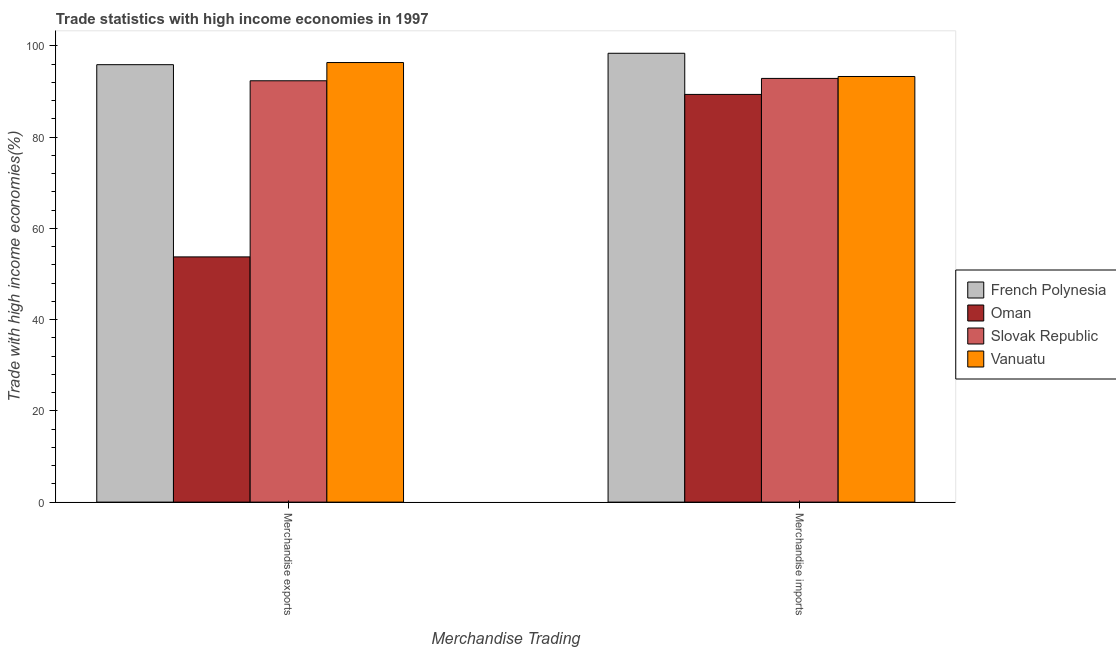How many different coloured bars are there?
Offer a very short reply. 4. Are the number of bars per tick equal to the number of legend labels?
Make the answer very short. Yes. Are the number of bars on each tick of the X-axis equal?
Offer a terse response. Yes. How many bars are there on the 1st tick from the right?
Give a very brief answer. 4. What is the merchandise exports in Oman?
Your answer should be compact. 53.76. Across all countries, what is the maximum merchandise imports?
Offer a terse response. 98.4. Across all countries, what is the minimum merchandise exports?
Provide a short and direct response. 53.76. In which country was the merchandise imports maximum?
Keep it short and to the point. French Polynesia. In which country was the merchandise exports minimum?
Offer a very short reply. Oman. What is the total merchandise imports in the graph?
Make the answer very short. 373.96. What is the difference between the merchandise imports in Slovak Republic and that in Vanuatu?
Keep it short and to the point. -0.42. What is the difference between the merchandise imports in French Polynesia and the merchandise exports in Slovak Republic?
Offer a terse response. 6.03. What is the average merchandise imports per country?
Your answer should be compact. 93.49. What is the difference between the merchandise imports and merchandise exports in French Polynesia?
Give a very brief answer. 2.5. In how many countries, is the merchandise imports greater than 56 %?
Offer a terse response. 4. What is the ratio of the merchandise exports in Slovak Republic to that in Vanuatu?
Provide a short and direct response. 0.96. What does the 4th bar from the left in Merchandise exports represents?
Give a very brief answer. Vanuatu. What does the 3rd bar from the right in Merchandise imports represents?
Make the answer very short. Oman. What is the difference between two consecutive major ticks on the Y-axis?
Your response must be concise. 20. Where does the legend appear in the graph?
Ensure brevity in your answer.  Center right. How are the legend labels stacked?
Provide a succinct answer. Vertical. What is the title of the graph?
Provide a succinct answer. Trade statistics with high income economies in 1997. Does "South Africa" appear as one of the legend labels in the graph?
Provide a short and direct response. No. What is the label or title of the X-axis?
Provide a short and direct response. Merchandise Trading. What is the label or title of the Y-axis?
Provide a succinct answer. Trade with high income economies(%). What is the Trade with high income economies(%) in French Polynesia in Merchandise exports?
Ensure brevity in your answer.  95.9. What is the Trade with high income economies(%) of Oman in Merchandise exports?
Ensure brevity in your answer.  53.76. What is the Trade with high income economies(%) of Slovak Republic in Merchandise exports?
Your answer should be compact. 92.37. What is the Trade with high income economies(%) in Vanuatu in Merchandise exports?
Your answer should be compact. 96.36. What is the Trade with high income economies(%) in French Polynesia in Merchandise imports?
Your response must be concise. 98.4. What is the Trade with high income economies(%) of Oman in Merchandise imports?
Your response must be concise. 89.38. What is the Trade with high income economies(%) in Slovak Republic in Merchandise imports?
Make the answer very short. 92.88. What is the Trade with high income economies(%) in Vanuatu in Merchandise imports?
Provide a succinct answer. 93.3. Across all Merchandise Trading, what is the maximum Trade with high income economies(%) in French Polynesia?
Offer a terse response. 98.4. Across all Merchandise Trading, what is the maximum Trade with high income economies(%) in Oman?
Give a very brief answer. 89.38. Across all Merchandise Trading, what is the maximum Trade with high income economies(%) in Slovak Republic?
Provide a succinct answer. 92.88. Across all Merchandise Trading, what is the maximum Trade with high income economies(%) in Vanuatu?
Make the answer very short. 96.36. Across all Merchandise Trading, what is the minimum Trade with high income economies(%) in French Polynesia?
Give a very brief answer. 95.9. Across all Merchandise Trading, what is the minimum Trade with high income economies(%) in Oman?
Your answer should be compact. 53.76. Across all Merchandise Trading, what is the minimum Trade with high income economies(%) of Slovak Republic?
Your response must be concise. 92.37. Across all Merchandise Trading, what is the minimum Trade with high income economies(%) of Vanuatu?
Your response must be concise. 93.3. What is the total Trade with high income economies(%) in French Polynesia in the graph?
Offer a very short reply. 194.29. What is the total Trade with high income economies(%) of Oman in the graph?
Your response must be concise. 143.14. What is the total Trade with high income economies(%) in Slovak Republic in the graph?
Provide a succinct answer. 185.25. What is the total Trade with high income economies(%) of Vanuatu in the graph?
Ensure brevity in your answer.  189.67. What is the difference between the Trade with high income economies(%) of French Polynesia in Merchandise exports and that in Merchandise imports?
Offer a terse response. -2.5. What is the difference between the Trade with high income economies(%) in Oman in Merchandise exports and that in Merchandise imports?
Provide a succinct answer. -35.62. What is the difference between the Trade with high income economies(%) of Slovak Republic in Merchandise exports and that in Merchandise imports?
Offer a very short reply. -0.52. What is the difference between the Trade with high income economies(%) in Vanuatu in Merchandise exports and that in Merchandise imports?
Your answer should be very brief. 3.06. What is the difference between the Trade with high income economies(%) in French Polynesia in Merchandise exports and the Trade with high income economies(%) in Oman in Merchandise imports?
Provide a succinct answer. 6.52. What is the difference between the Trade with high income economies(%) of French Polynesia in Merchandise exports and the Trade with high income economies(%) of Slovak Republic in Merchandise imports?
Your answer should be compact. 3.01. What is the difference between the Trade with high income economies(%) in French Polynesia in Merchandise exports and the Trade with high income economies(%) in Vanuatu in Merchandise imports?
Offer a terse response. 2.59. What is the difference between the Trade with high income economies(%) in Oman in Merchandise exports and the Trade with high income economies(%) in Slovak Republic in Merchandise imports?
Make the answer very short. -39.13. What is the difference between the Trade with high income economies(%) of Oman in Merchandise exports and the Trade with high income economies(%) of Vanuatu in Merchandise imports?
Ensure brevity in your answer.  -39.55. What is the difference between the Trade with high income economies(%) of Slovak Republic in Merchandise exports and the Trade with high income economies(%) of Vanuatu in Merchandise imports?
Provide a short and direct response. -0.94. What is the average Trade with high income economies(%) of French Polynesia per Merchandise Trading?
Offer a very short reply. 97.15. What is the average Trade with high income economies(%) of Oman per Merchandise Trading?
Offer a terse response. 71.57. What is the average Trade with high income economies(%) in Slovak Republic per Merchandise Trading?
Make the answer very short. 92.63. What is the average Trade with high income economies(%) in Vanuatu per Merchandise Trading?
Your answer should be very brief. 94.83. What is the difference between the Trade with high income economies(%) in French Polynesia and Trade with high income economies(%) in Oman in Merchandise exports?
Provide a succinct answer. 42.14. What is the difference between the Trade with high income economies(%) in French Polynesia and Trade with high income economies(%) in Slovak Republic in Merchandise exports?
Offer a terse response. 3.53. What is the difference between the Trade with high income economies(%) of French Polynesia and Trade with high income economies(%) of Vanuatu in Merchandise exports?
Your response must be concise. -0.47. What is the difference between the Trade with high income economies(%) in Oman and Trade with high income economies(%) in Slovak Republic in Merchandise exports?
Provide a succinct answer. -38.61. What is the difference between the Trade with high income economies(%) in Oman and Trade with high income economies(%) in Vanuatu in Merchandise exports?
Keep it short and to the point. -42.61. What is the difference between the Trade with high income economies(%) in Slovak Republic and Trade with high income economies(%) in Vanuatu in Merchandise exports?
Your answer should be compact. -4. What is the difference between the Trade with high income economies(%) in French Polynesia and Trade with high income economies(%) in Oman in Merchandise imports?
Ensure brevity in your answer.  9.02. What is the difference between the Trade with high income economies(%) in French Polynesia and Trade with high income economies(%) in Slovak Republic in Merchandise imports?
Your response must be concise. 5.51. What is the difference between the Trade with high income economies(%) in French Polynesia and Trade with high income economies(%) in Vanuatu in Merchandise imports?
Ensure brevity in your answer.  5.09. What is the difference between the Trade with high income economies(%) in Oman and Trade with high income economies(%) in Slovak Republic in Merchandise imports?
Your response must be concise. -3.5. What is the difference between the Trade with high income economies(%) of Oman and Trade with high income economies(%) of Vanuatu in Merchandise imports?
Provide a succinct answer. -3.93. What is the difference between the Trade with high income economies(%) in Slovak Republic and Trade with high income economies(%) in Vanuatu in Merchandise imports?
Your response must be concise. -0.42. What is the ratio of the Trade with high income economies(%) in French Polynesia in Merchandise exports to that in Merchandise imports?
Your answer should be very brief. 0.97. What is the ratio of the Trade with high income economies(%) in Oman in Merchandise exports to that in Merchandise imports?
Make the answer very short. 0.6. What is the ratio of the Trade with high income economies(%) of Slovak Republic in Merchandise exports to that in Merchandise imports?
Your answer should be compact. 0.99. What is the ratio of the Trade with high income economies(%) of Vanuatu in Merchandise exports to that in Merchandise imports?
Give a very brief answer. 1.03. What is the difference between the highest and the second highest Trade with high income economies(%) in French Polynesia?
Your answer should be compact. 2.5. What is the difference between the highest and the second highest Trade with high income economies(%) in Oman?
Provide a short and direct response. 35.62. What is the difference between the highest and the second highest Trade with high income economies(%) of Slovak Republic?
Offer a terse response. 0.52. What is the difference between the highest and the second highest Trade with high income economies(%) in Vanuatu?
Offer a terse response. 3.06. What is the difference between the highest and the lowest Trade with high income economies(%) of French Polynesia?
Ensure brevity in your answer.  2.5. What is the difference between the highest and the lowest Trade with high income economies(%) in Oman?
Your response must be concise. 35.62. What is the difference between the highest and the lowest Trade with high income economies(%) of Slovak Republic?
Offer a terse response. 0.52. What is the difference between the highest and the lowest Trade with high income economies(%) in Vanuatu?
Make the answer very short. 3.06. 